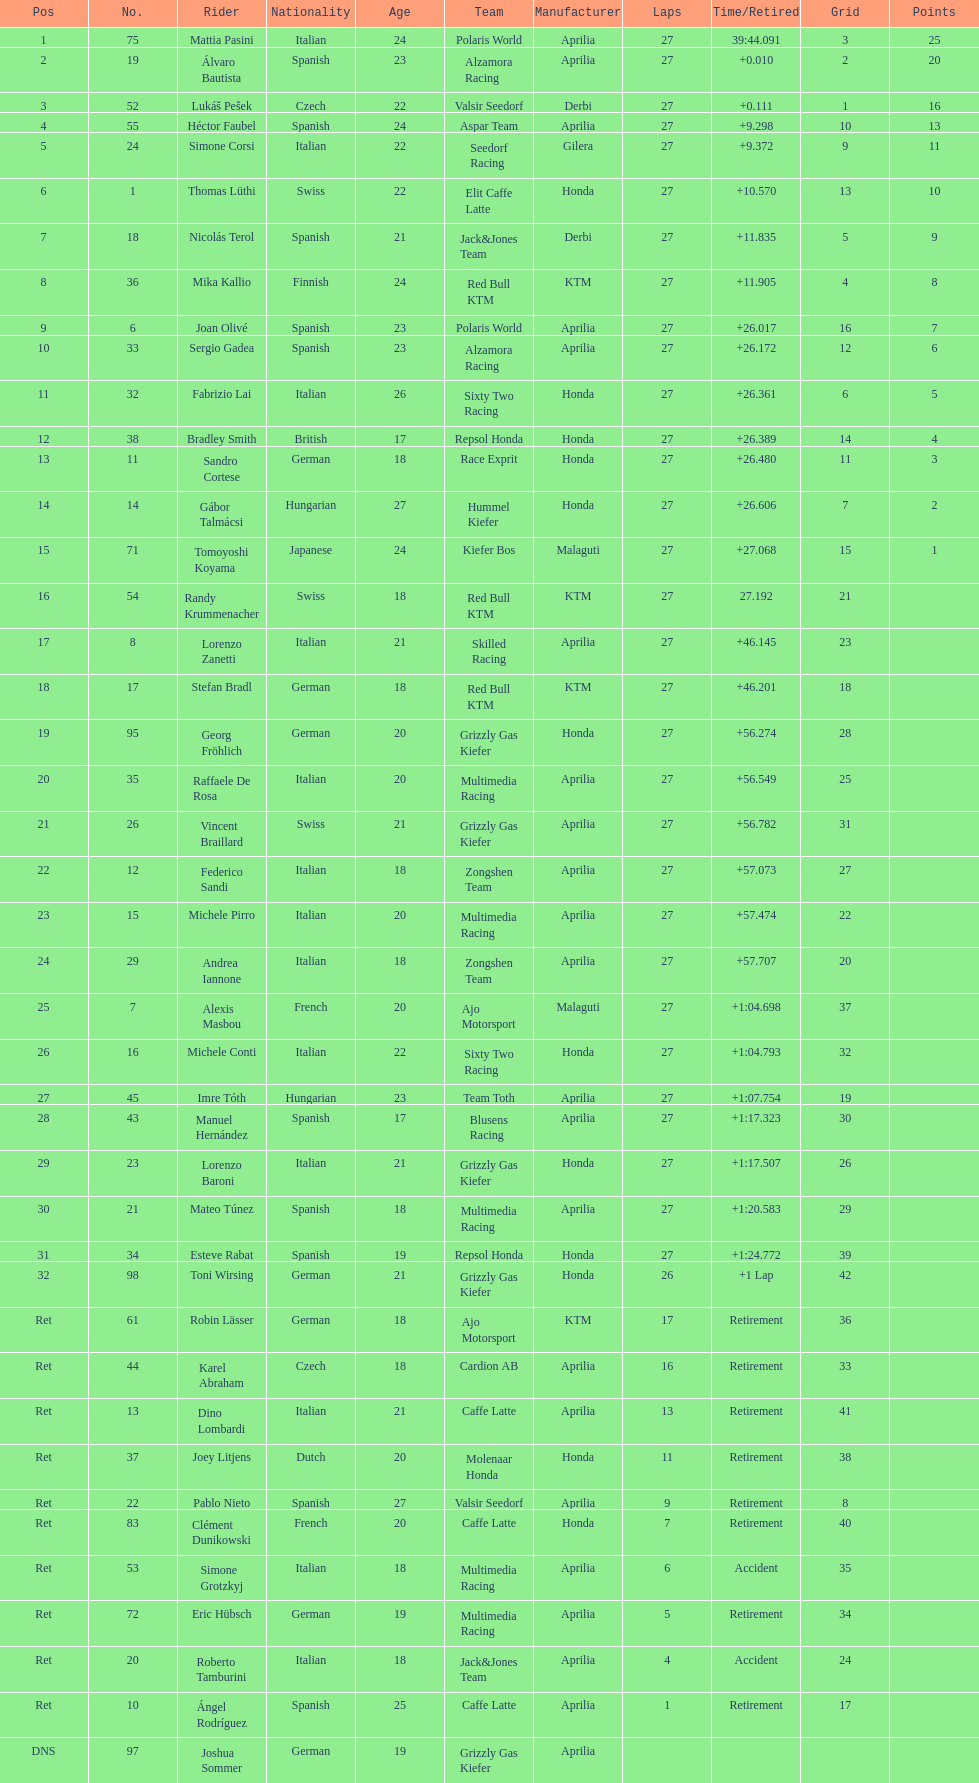Who placed higher, bradl or gadea? Sergio Gadea. 